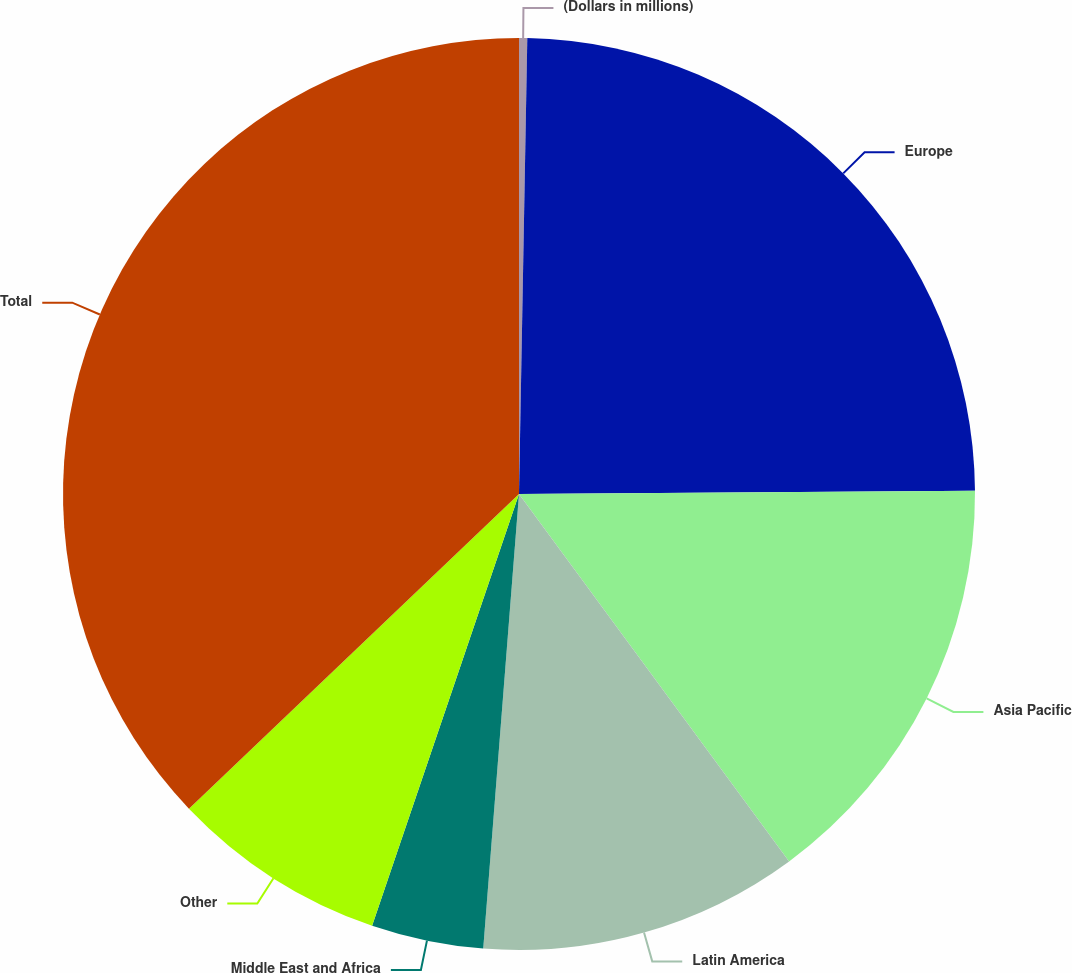Convert chart. <chart><loc_0><loc_0><loc_500><loc_500><pie_chart><fcel>(Dollars in millions)<fcel>Europe<fcel>Asia Pacific<fcel>Latin America<fcel>Middle East and Africa<fcel>Other<fcel>Total<nl><fcel>0.29%<fcel>24.6%<fcel>15.02%<fcel>11.34%<fcel>3.97%<fcel>7.66%<fcel>37.12%<nl></chart> 